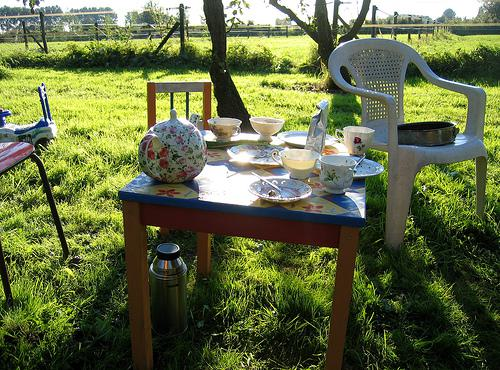Would there be a chair in the image if there was no chair in the image? No, if there was no chair originally in the image, then logically, there couldn't be a chair appearing without changes made to the image. 